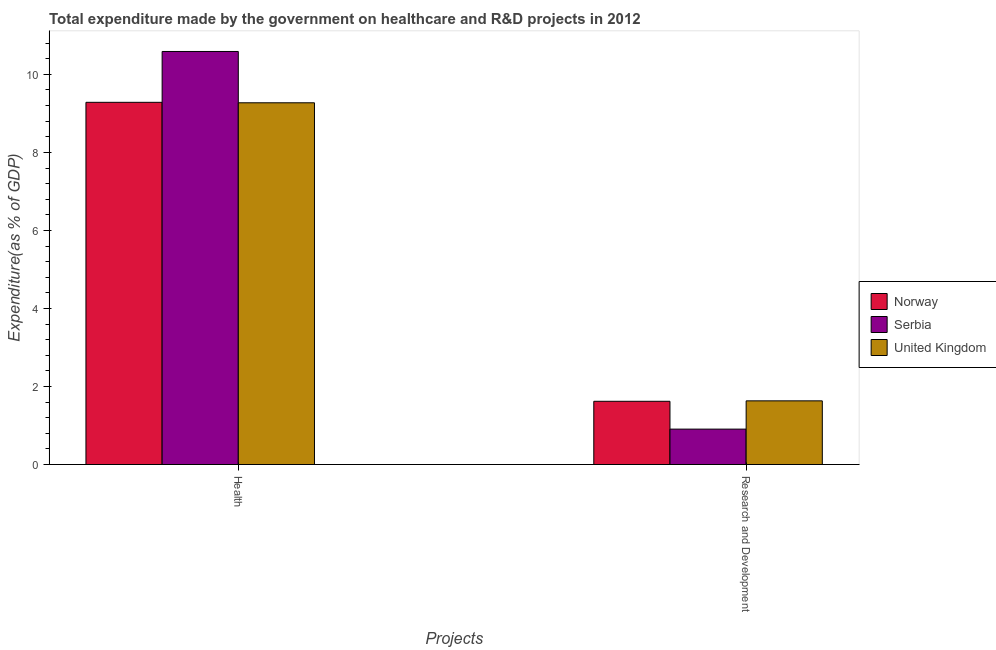How many groups of bars are there?
Make the answer very short. 2. Are the number of bars per tick equal to the number of legend labels?
Offer a very short reply. Yes. What is the label of the 1st group of bars from the left?
Offer a very short reply. Health. What is the expenditure in r&d in Norway?
Your answer should be very brief. 1.62. Across all countries, what is the maximum expenditure in healthcare?
Your answer should be compact. 10.59. Across all countries, what is the minimum expenditure in r&d?
Offer a terse response. 0.91. In which country was the expenditure in healthcare maximum?
Your response must be concise. Serbia. In which country was the expenditure in r&d minimum?
Keep it short and to the point. Serbia. What is the total expenditure in r&d in the graph?
Your response must be concise. 4.16. What is the difference between the expenditure in healthcare in Serbia and that in United Kingdom?
Your answer should be very brief. 1.32. What is the difference between the expenditure in healthcare in Norway and the expenditure in r&d in Serbia?
Ensure brevity in your answer.  8.38. What is the average expenditure in r&d per country?
Your answer should be compact. 1.39. What is the difference between the expenditure in r&d and expenditure in healthcare in United Kingdom?
Provide a succinct answer. -7.64. In how many countries, is the expenditure in r&d greater than 4 %?
Your answer should be very brief. 0. What is the ratio of the expenditure in r&d in United Kingdom to that in Serbia?
Provide a short and direct response. 1.8. What does the 1st bar from the left in Health represents?
Give a very brief answer. Norway. How many bars are there?
Keep it short and to the point. 6. How many countries are there in the graph?
Your answer should be compact. 3. What is the difference between two consecutive major ticks on the Y-axis?
Keep it short and to the point. 2. Are the values on the major ticks of Y-axis written in scientific E-notation?
Provide a succinct answer. No. Does the graph contain any zero values?
Your answer should be compact. No. Where does the legend appear in the graph?
Make the answer very short. Center right. How many legend labels are there?
Provide a short and direct response. 3. How are the legend labels stacked?
Ensure brevity in your answer.  Vertical. What is the title of the graph?
Ensure brevity in your answer.  Total expenditure made by the government on healthcare and R&D projects in 2012. What is the label or title of the X-axis?
Provide a short and direct response. Projects. What is the label or title of the Y-axis?
Offer a terse response. Expenditure(as % of GDP). What is the Expenditure(as % of GDP) in Norway in Health?
Your answer should be very brief. 9.28. What is the Expenditure(as % of GDP) of Serbia in Health?
Provide a succinct answer. 10.59. What is the Expenditure(as % of GDP) of United Kingdom in Health?
Your response must be concise. 9.27. What is the Expenditure(as % of GDP) of Norway in Research and Development?
Your answer should be compact. 1.62. What is the Expenditure(as % of GDP) in Serbia in Research and Development?
Offer a very short reply. 0.91. What is the Expenditure(as % of GDP) of United Kingdom in Research and Development?
Give a very brief answer. 1.63. Across all Projects, what is the maximum Expenditure(as % of GDP) of Norway?
Your answer should be very brief. 9.28. Across all Projects, what is the maximum Expenditure(as % of GDP) in Serbia?
Keep it short and to the point. 10.59. Across all Projects, what is the maximum Expenditure(as % of GDP) of United Kingdom?
Give a very brief answer. 9.27. Across all Projects, what is the minimum Expenditure(as % of GDP) of Norway?
Make the answer very short. 1.62. Across all Projects, what is the minimum Expenditure(as % of GDP) of Serbia?
Provide a short and direct response. 0.91. Across all Projects, what is the minimum Expenditure(as % of GDP) of United Kingdom?
Provide a short and direct response. 1.63. What is the total Expenditure(as % of GDP) in Norway in the graph?
Ensure brevity in your answer.  10.9. What is the total Expenditure(as % of GDP) of Serbia in the graph?
Ensure brevity in your answer.  11.49. What is the total Expenditure(as % of GDP) of United Kingdom in the graph?
Your response must be concise. 10.9. What is the difference between the Expenditure(as % of GDP) of Norway in Health and that in Research and Development?
Offer a terse response. 7.66. What is the difference between the Expenditure(as % of GDP) in Serbia in Health and that in Research and Development?
Your answer should be compact. 9.68. What is the difference between the Expenditure(as % of GDP) in United Kingdom in Health and that in Research and Development?
Make the answer very short. 7.64. What is the difference between the Expenditure(as % of GDP) in Norway in Health and the Expenditure(as % of GDP) in Serbia in Research and Development?
Offer a very short reply. 8.38. What is the difference between the Expenditure(as % of GDP) in Norway in Health and the Expenditure(as % of GDP) in United Kingdom in Research and Development?
Make the answer very short. 7.65. What is the difference between the Expenditure(as % of GDP) of Serbia in Health and the Expenditure(as % of GDP) of United Kingdom in Research and Development?
Give a very brief answer. 8.96. What is the average Expenditure(as % of GDP) in Norway per Projects?
Ensure brevity in your answer.  5.45. What is the average Expenditure(as % of GDP) in Serbia per Projects?
Provide a short and direct response. 5.75. What is the average Expenditure(as % of GDP) of United Kingdom per Projects?
Your answer should be very brief. 5.45. What is the difference between the Expenditure(as % of GDP) in Norway and Expenditure(as % of GDP) in Serbia in Health?
Give a very brief answer. -1.3. What is the difference between the Expenditure(as % of GDP) of Norway and Expenditure(as % of GDP) of United Kingdom in Health?
Offer a terse response. 0.01. What is the difference between the Expenditure(as % of GDP) of Serbia and Expenditure(as % of GDP) of United Kingdom in Health?
Give a very brief answer. 1.32. What is the difference between the Expenditure(as % of GDP) of Norway and Expenditure(as % of GDP) of Serbia in Research and Development?
Offer a very short reply. 0.71. What is the difference between the Expenditure(as % of GDP) of Norway and Expenditure(as % of GDP) of United Kingdom in Research and Development?
Offer a terse response. -0.01. What is the difference between the Expenditure(as % of GDP) of Serbia and Expenditure(as % of GDP) of United Kingdom in Research and Development?
Make the answer very short. -0.72. What is the ratio of the Expenditure(as % of GDP) of Norway in Health to that in Research and Development?
Provide a succinct answer. 5.73. What is the ratio of the Expenditure(as % of GDP) in Serbia in Health to that in Research and Development?
Offer a terse response. 11.67. What is the ratio of the Expenditure(as % of GDP) of United Kingdom in Health to that in Research and Development?
Offer a terse response. 5.68. What is the difference between the highest and the second highest Expenditure(as % of GDP) of Norway?
Ensure brevity in your answer.  7.66. What is the difference between the highest and the second highest Expenditure(as % of GDP) of Serbia?
Provide a succinct answer. 9.68. What is the difference between the highest and the second highest Expenditure(as % of GDP) of United Kingdom?
Offer a terse response. 7.64. What is the difference between the highest and the lowest Expenditure(as % of GDP) of Norway?
Give a very brief answer. 7.66. What is the difference between the highest and the lowest Expenditure(as % of GDP) of Serbia?
Offer a very short reply. 9.68. What is the difference between the highest and the lowest Expenditure(as % of GDP) in United Kingdom?
Your answer should be very brief. 7.64. 